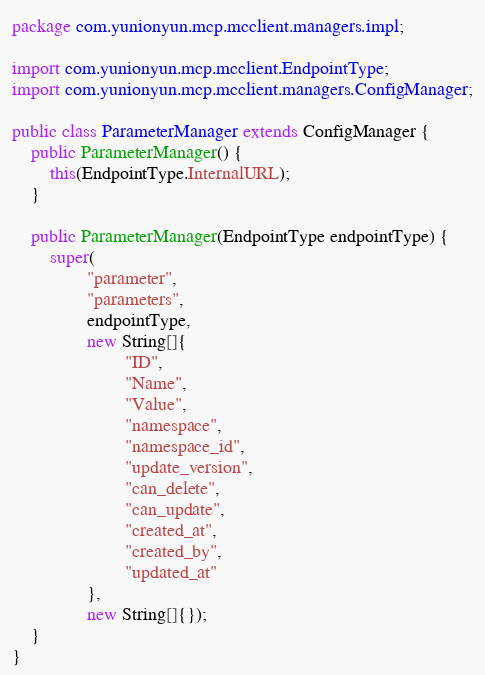<code> <loc_0><loc_0><loc_500><loc_500><_Java_>package com.yunionyun.mcp.mcclient.managers.impl;

import com.yunionyun.mcp.mcclient.EndpointType;
import com.yunionyun.mcp.mcclient.managers.ConfigManager;

public class ParameterManager extends ConfigManager {
	public ParameterManager() {
		this(EndpointType.InternalURL);
	}

	public ParameterManager(EndpointType endpointType) {
		super(
				"parameter",
				"parameters",
				endpointType,
				new String[]{
						"ID",
						"Name",
						"Value",
						"namespace",
						"namespace_id",
						"update_version",
						"can_delete",
						"can_update",
						"created_at",
						"created_by",
						"updated_at"
				},
				new String[]{});
	}
}
</code> 